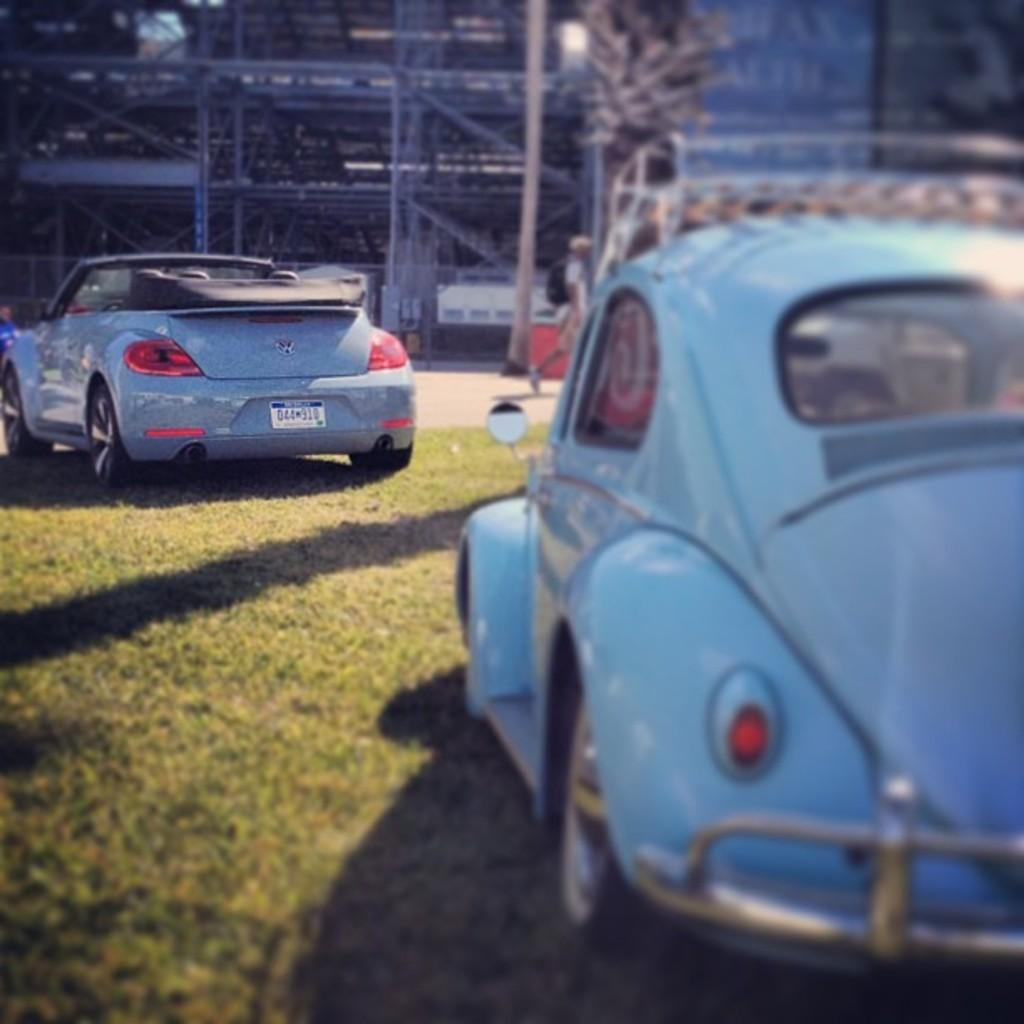What is the main subject of the image? The main subject of the image is two cars parked on the grass. Where are the cars located in relation to the grass? The cars are parked on the surface of the grass. What can be seen at the center of the image? There is a road at the center of the image. What is visible in the background of the image? There are buildings in the background of the image. Can you tell me how many waves are visible in the image? There are no waves present in the image; it features two cars parked on the grass and a road at the center. What type of division is being taught in the image? There is no indication of any division or educational activity in the image. 